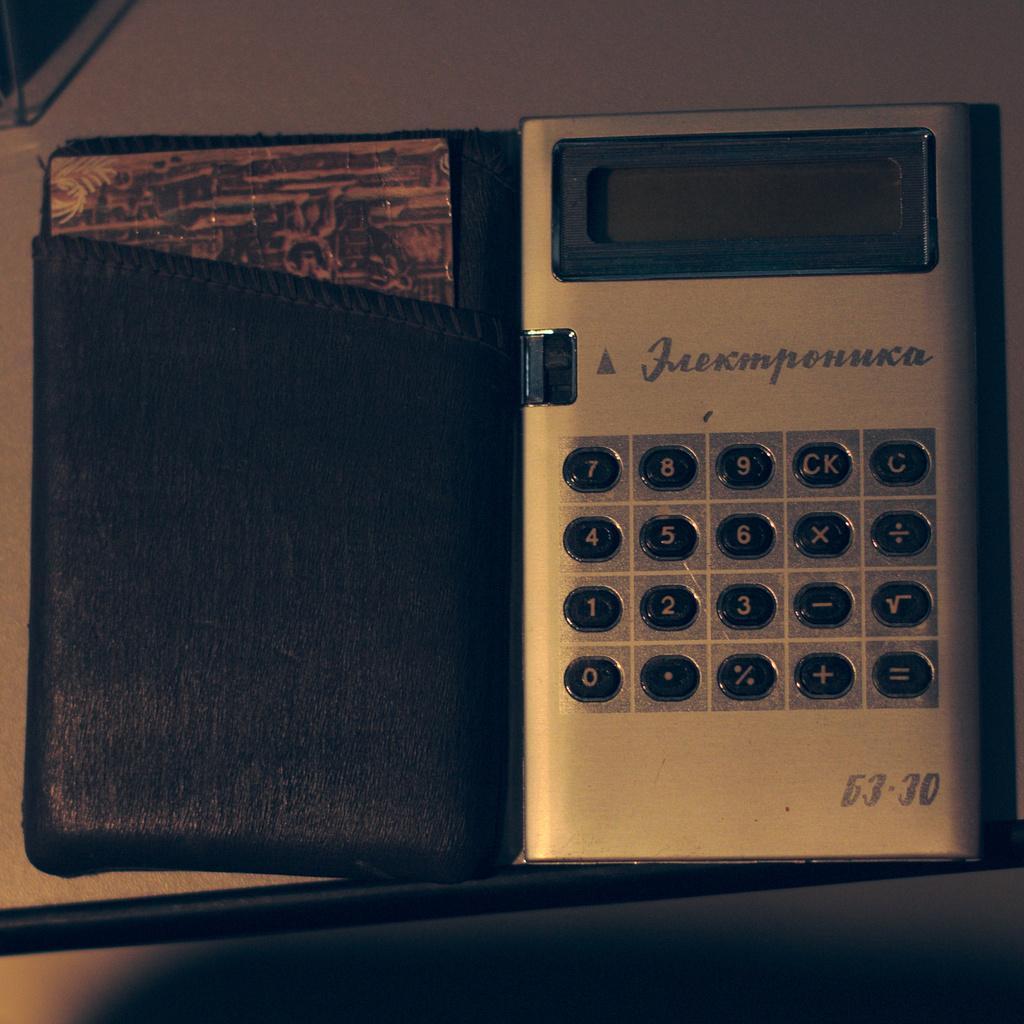In one or two sentences, can you explain what this image depicts? In this picture there is a calculator and there is text and there are numbers on the calculator and there is a card in the cover. At the back there is an object. At the bottom it looks like a table. 